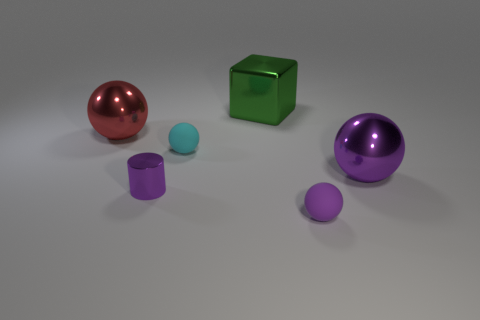Could you describe the lighting in the scene? The lighting appears uniform and diffused, with soft shadows beneath each object, suggesting an overhead light source with no strong directional bias. 